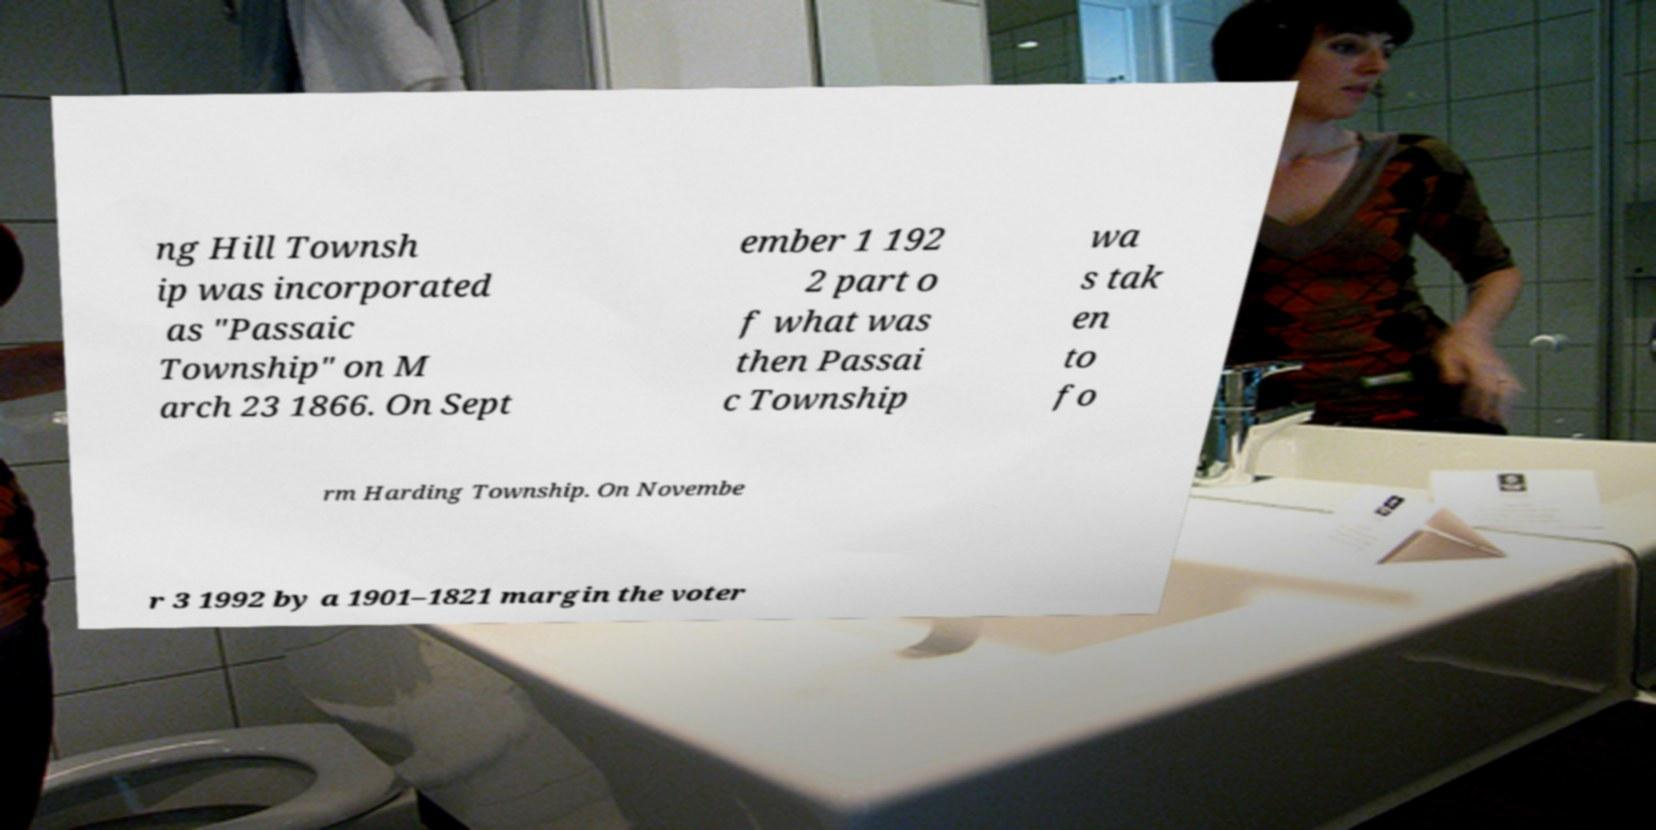Could you assist in decoding the text presented in this image and type it out clearly? ng Hill Townsh ip was incorporated as "Passaic Township" on M arch 23 1866. On Sept ember 1 192 2 part o f what was then Passai c Township wa s tak en to fo rm Harding Township. On Novembe r 3 1992 by a 1901–1821 margin the voter 